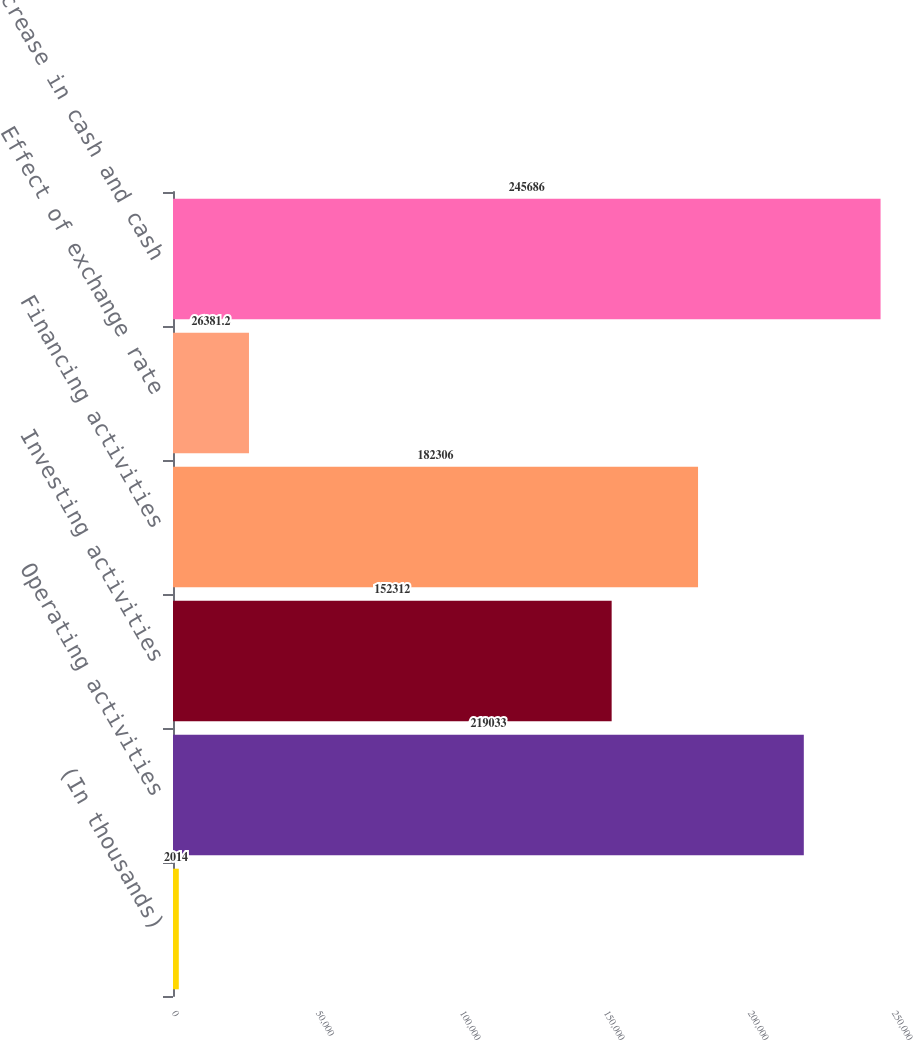Convert chart to OTSL. <chart><loc_0><loc_0><loc_500><loc_500><bar_chart><fcel>(In thousands)<fcel>Operating activities<fcel>Investing activities<fcel>Financing activities<fcel>Effect of exchange rate<fcel>Net increase in cash and cash<nl><fcel>2014<fcel>219033<fcel>152312<fcel>182306<fcel>26381.2<fcel>245686<nl></chart> 